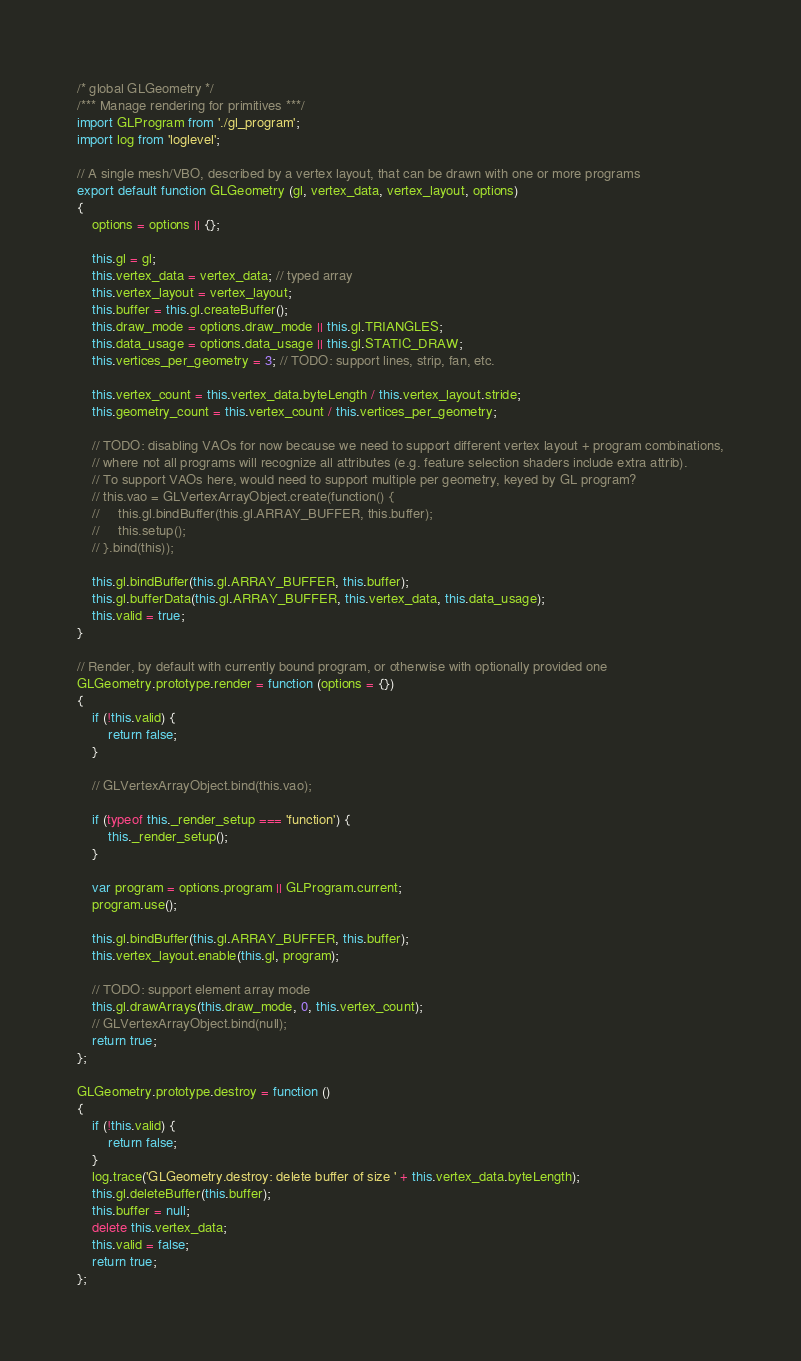<code> <loc_0><loc_0><loc_500><loc_500><_JavaScript_>/* global GLGeometry */
/*** Manage rendering for primitives ***/
import GLProgram from './gl_program';
import log from 'loglevel';

// A single mesh/VBO, described by a vertex layout, that can be drawn with one or more programs
export default function GLGeometry (gl, vertex_data, vertex_layout, options)
{
    options = options || {};

    this.gl = gl;
    this.vertex_data = vertex_data; // typed array
    this.vertex_layout = vertex_layout;
    this.buffer = this.gl.createBuffer();
    this.draw_mode = options.draw_mode || this.gl.TRIANGLES;
    this.data_usage = options.data_usage || this.gl.STATIC_DRAW;
    this.vertices_per_geometry = 3; // TODO: support lines, strip, fan, etc.

    this.vertex_count = this.vertex_data.byteLength / this.vertex_layout.stride;
    this.geometry_count = this.vertex_count / this.vertices_per_geometry;

    // TODO: disabling VAOs for now because we need to support different vertex layout + program combinations,
    // where not all programs will recognize all attributes (e.g. feature selection shaders include extra attrib).
    // To support VAOs here, would need to support multiple per geometry, keyed by GL program?
    // this.vao = GLVertexArrayObject.create(function() {
    //     this.gl.bindBuffer(this.gl.ARRAY_BUFFER, this.buffer);
    //     this.setup();
    // }.bind(this));

    this.gl.bindBuffer(this.gl.ARRAY_BUFFER, this.buffer);
    this.gl.bufferData(this.gl.ARRAY_BUFFER, this.vertex_data, this.data_usage);
    this.valid = true;
}

// Render, by default with currently bound program, or otherwise with optionally provided one
GLGeometry.prototype.render = function (options = {})
{
    if (!this.valid) {
        return false;
    }

    // GLVertexArrayObject.bind(this.vao);

    if (typeof this._render_setup === 'function') {
        this._render_setup();
    }

    var program = options.program || GLProgram.current;
    program.use();

    this.gl.bindBuffer(this.gl.ARRAY_BUFFER, this.buffer);
    this.vertex_layout.enable(this.gl, program);

    // TODO: support element array mode
    this.gl.drawArrays(this.draw_mode, 0, this.vertex_count);
    // GLVertexArrayObject.bind(null);
    return true;
};

GLGeometry.prototype.destroy = function ()
{
    if (!this.valid) {
        return false;
    }
    log.trace('GLGeometry.destroy: delete buffer of size ' + this.vertex_data.byteLength);
    this.gl.deleteBuffer(this.buffer);
    this.buffer = null;
    delete this.vertex_data;
    this.valid = false;
    return true;
};
</code> 